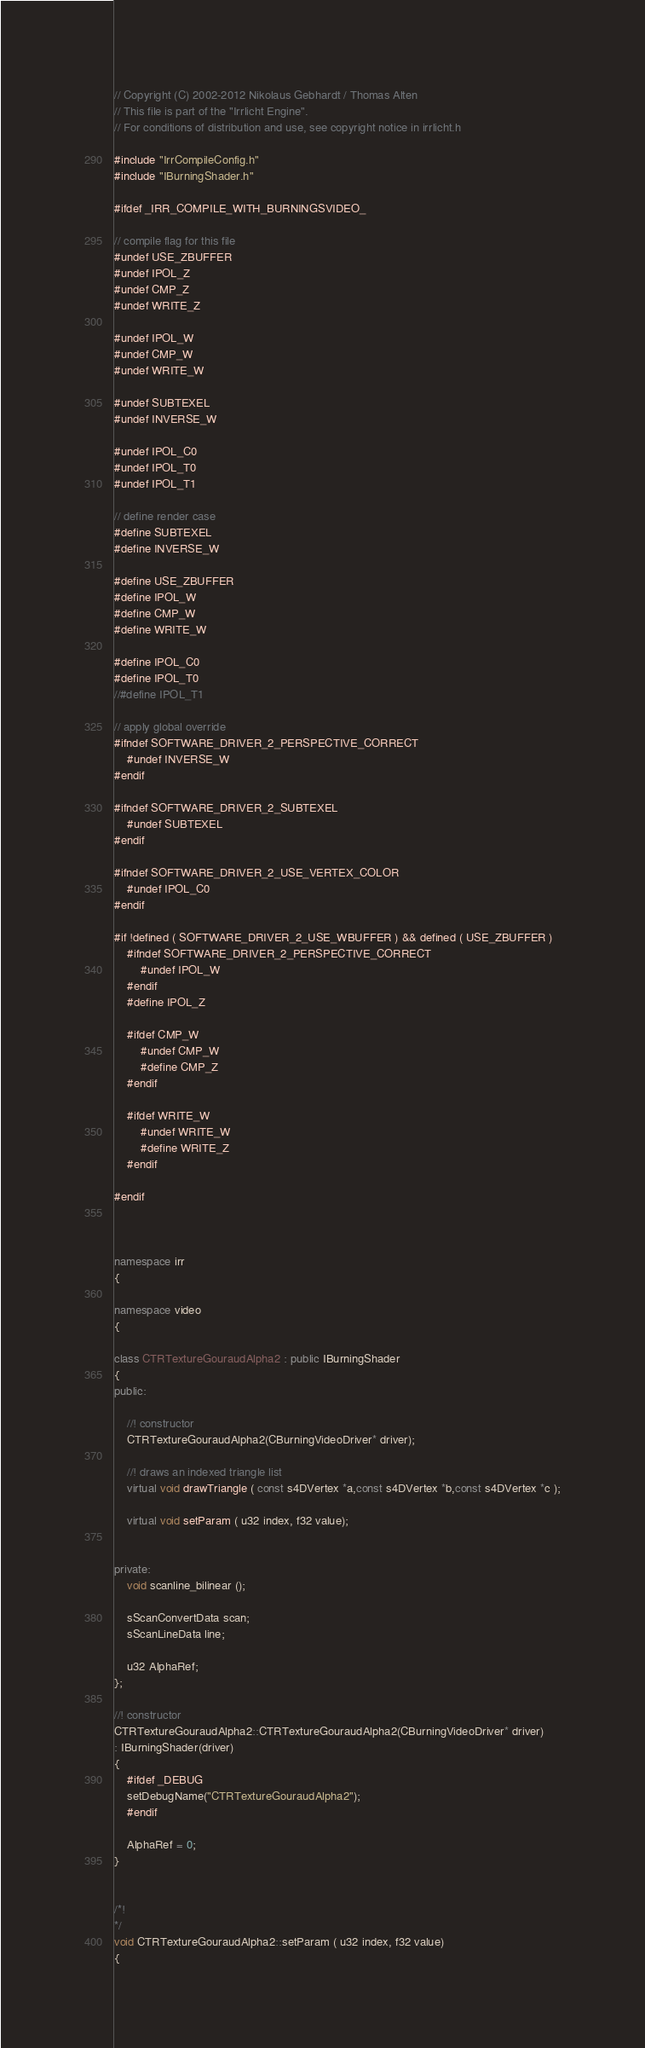<code> <loc_0><loc_0><loc_500><loc_500><_C++_>// Copyright (C) 2002-2012 Nikolaus Gebhardt / Thomas Alten
// This file is part of the "Irrlicht Engine".
// For conditions of distribution and use, see copyright notice in irrlicht.h

#include "IrrCompileConfig.h"
#include "IBurningShader.h"

#ifdef _IRR_COMPILE_WITH_BURNINGSVIDEO_

// compile flag for this file
#undef USE_ZBUFFER
#undef IPOL_Z
#undef CMP_Z
#undef WRITE_Z

#undef IPOL_W
#undef CMP_W
#undef WRITE_W

#undef SUBTEXEL
#undef INVERSE_W

#undef IPOL_C0
#undef IPOL_T0
#undef IPOL_T1

// define render case
#define SUBTEXEL
#define INVERSE_W

#define USE_ZBUFFER
#define IPOL_W
#define CMP_W
#define WRITE_W

#define IPOL_C0
#define IPOL_T0
//#define IPOL_T1

// apply global override
#ifndef SOFTWARE_DRIVER_2_PERSPECTIVE_CORRECT
	#undef INVERSE_W
#endif

#ifndef SOFTWARE_DRIVER_2_SUBTEXEL
	#undef SUBTEXEL
#endif

#ifndef SOFTWARE_DRIVER_2_USE_VERTEX_COLOR
	#undef IPOL_C0
#endif

#if !defined ( SOFTWARE_DRIVER_2_USE_WBUFFER ) && defined ( USE_ZBUFFER )
	#ifndef SOFTWARE_DRIVER_2_PERSPECTIVE_CORRECT
		#undef IPOL_W
	#endif
	#define IPOL_Z

	#ifdef CMP_W
		#undef CMP_W
		#define CMP_Z
	#endif

	#ifdef WRITE_W
		#undef WRITE_W
		#define WRITE_Z
	#endif

#endif



namespace irr
{

namespace video
{

class CTRTextureGouraudAlpha2 : public IBurningShader
{
public:

	//! constructor
	CTRTextureGouraudAlpha2(CBurningVideoDriver* driver);

	//! draws an indexed triangle list
	virtual void drawTriangle ( const s4DVertex *a,const s4DVertex *b,const s4DVertex *c );

	virtual void setParam ( u32 index, f32 value);


private:
	void scanline_bilinear ();

	sScanConvertData scan;
	sScanLineData line;

	u32 AlphaRef;
};

//! constructor
CTRTextureGouraudAlpha2::CTRTextureGouraudAlpha2(CBurningVideoDriver* driver)
: IBurningShader(driver)
{
	#ifdef _DEBUG
	setDebugName("CTRTextureGouraudAlpha2");
	#endif

	AlphaRef = 0;
}


/*!
*/
void CTRTextureGouraudAlpha2::setParam ( u32 index, f32 value)
{</code> 